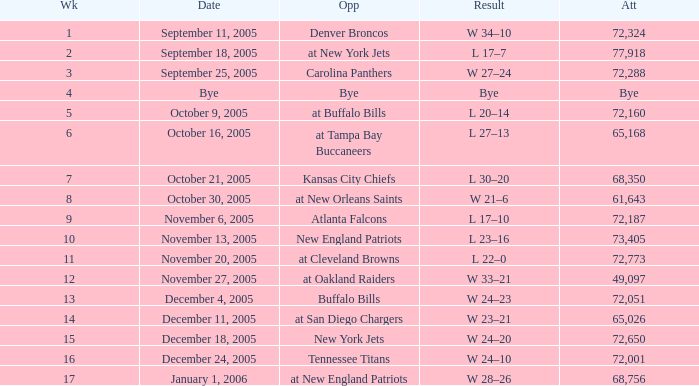On what Date was the Attendance 73,405? November 13, 2005. 